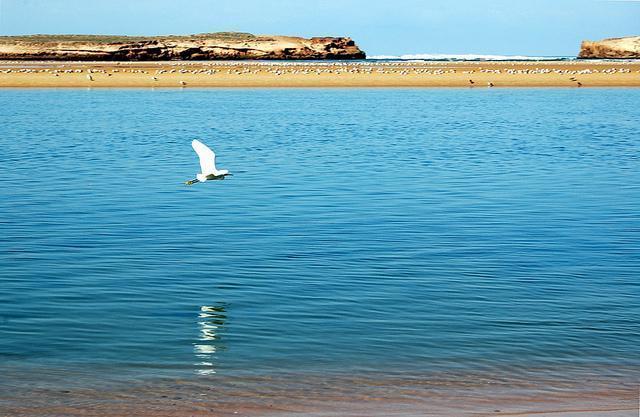How many dark brown horses are there?
Give a very brief answer. 0. 